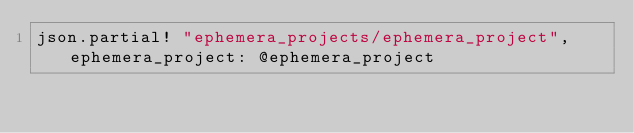Convert code to text. <code><loc_0><loc_0><loc_500><loc_500><_Ruby_>json.partial! "ephemera_projects/ephemera_project", ephemera_project: @ephemera_project
</code> 